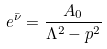Convert formula to latex. <formula><loc_0><loc_0><loc_500><loc_500>e ^ { \bar { \nu } } = \frac { A _ { 0 } } { \Lambda ^ { 2 } - p ^ { 2 } }</formula> 